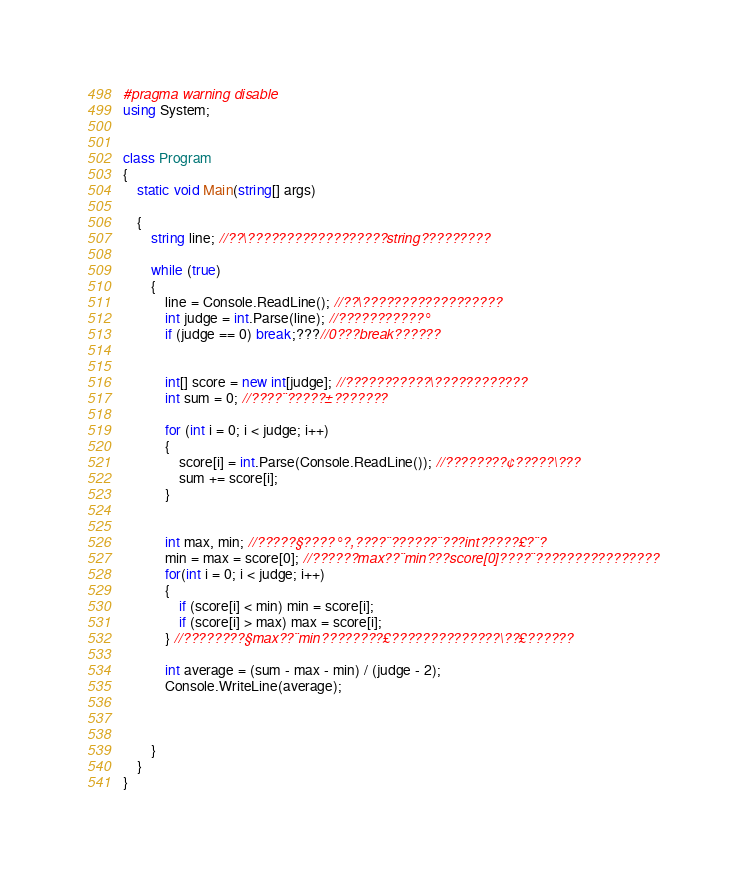Convert code to text. <code><loc_0><loc_0><loc_500><loc_500><_C#_>#pragma warning disable
using System;


class Program
{
    static void Main(string[] args)

    {
        string line; //??\??????????????????string?????????

        while (true)
        {
            line = Console.ReadLine(); //??\??????????????????
            int judge = int.Parse(line); //???????????°
            if (judge == 0) break;???//0???break??????


            int[] score = new int[judge]; //???????????\????????????
            int sum = 0; //????¨?????±???????

            for (int i = 0; i < judge; i++)
            {
                score[i] = int.Parse(Console.ReadLine()); //????????¢?????\???
                sum += score[i];
            }


            int max, min; //?????§????°?,????¨??????¨???int?????£?¨?
            min = max = score[0]; //??????max??¨min???score[0]????¨????????????????
            for(int i = 0; i < judge; i++)
            {
                if (score[i] < min) min = score[i];
                if (score[i] > max) max = score[i];
            } //????????§max??¨min????????£??????????????\??£??????

            int average = (sum - max - min) / (judge - 2);
            Console.WriteLine(average);

            
          
        }
    }
}</code> 